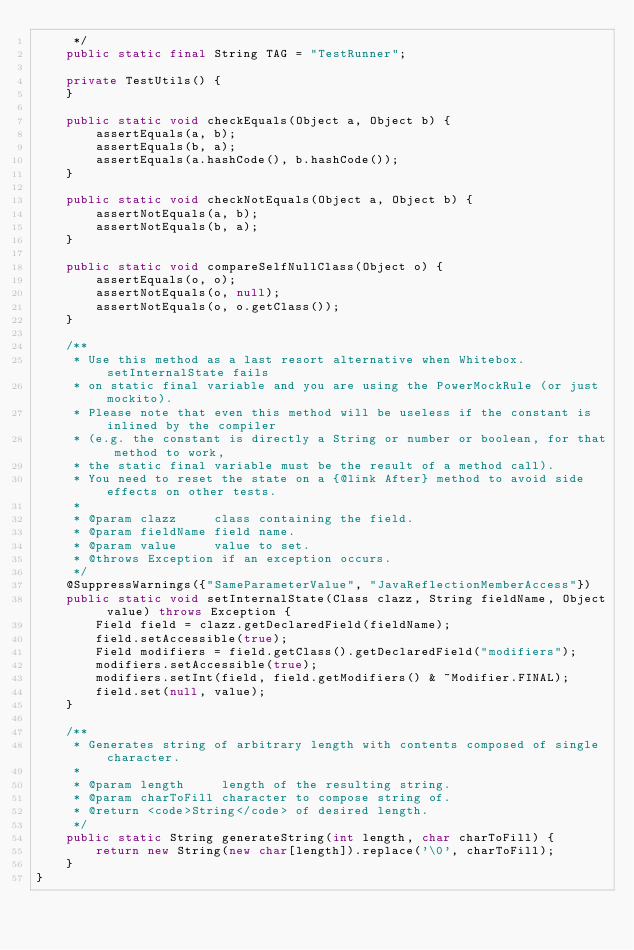<code> <loc_0><loc_0><loc_500><loc_500><_Java_>     */
    public static final String TAG = "TestRunner";

    private TestUtils() {
    }

    public static void checkEquals(Object a, Object b) {
        assertEquals(a, b);
        assertEquals(b, a);
        assertEquals(a.hashCode(), b.hashCode());
    }

    public static void checkNotEquals(Object a, Object b) {
        assertNotEquals(a, b);
        assertNotEquals(b, a);
    }

    public static void compareSelfNullClass(Object o) {
        assertEquals(o, o);
        assertNotEquals(o, null);
        assertNotEquals(o, o.getClass());
    }

    /**
     * Use this method as a last resort alternative when Whitebox.setInternalState fails
     * on static final variable and you are using the PowerMockRule (or just mockito).
     * Please note that even this method will be useless if the constant is inlined by the compiler
     * (e.g. the constant is directly a String or number or boolean, for that method to work,
     * the static final variable must be the result of a method call).
     * You need to reset the state on a {@link After} method to avoid side effects on other tests.
     *
     * @param clazz     class containing the field.
     * @param fieldName field name.
     * @param value     value to set.
     * @throws Exception if an exception occurs.
     */
    @SuppressWarnings({"SameParameterValue", "JavaReflectionMemberAccess"})
    public static void setInternalState(Class clazz, String fieldName, Object value) throws Exception {
        Field field = clazz.getDeclaredField(fieldName);
        field.setAccessible(true);
        Field modifiers = field.getClass().getDeclaredField("modifiers");
        modifiers.setAccessible(true);
        modifiers.setInt(field, field.getModifiers() & ~Modifier.FINAL);
        field.set(null, value);
    }

    /**
     * Generates string of arbitrary length with contents composed of single character.
     *
     * @param length     length of the resulting string.
     * @param charToFill character to compose string of.
     * @return <code>String</code> of desired length.
     */
    public static String generateString(int length, char charToFill) {
        return new String(new char[length]).replace('\0', charToFill);
    }
}
</code> 